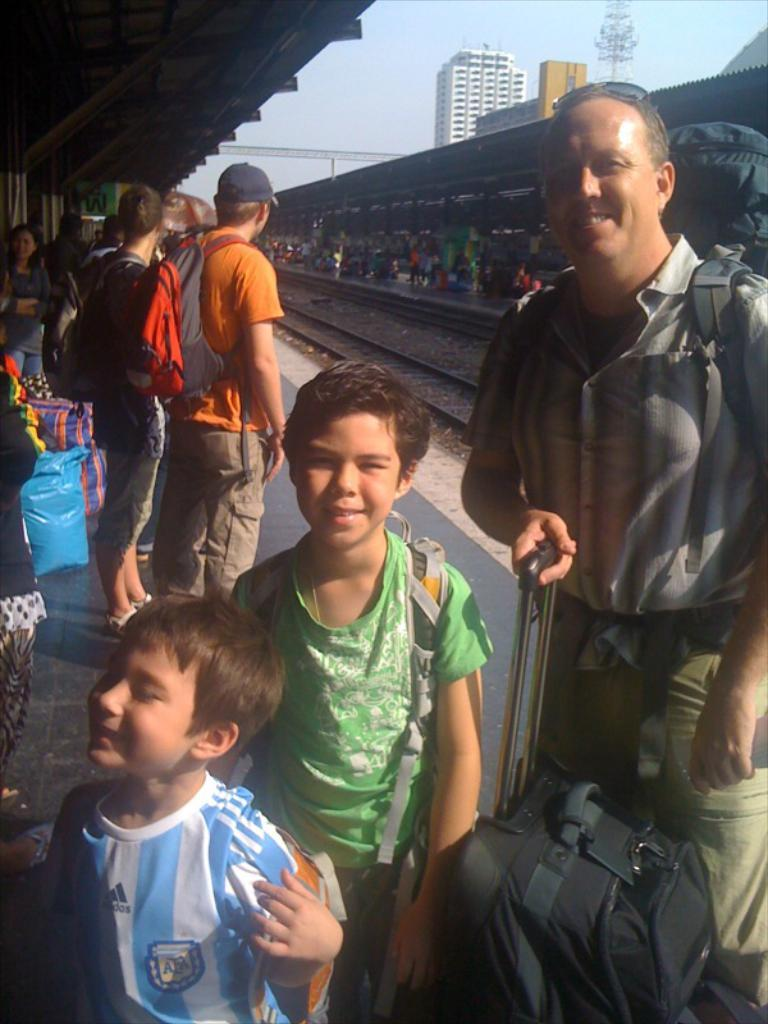What are the people in the image doing? The people in the image are standing on a platform. Can you describe the man on the left side of the platform? The man on the left side of the platform is holding a briefcase. What can be seen in the background of the image? There are railway tracks, buildings, and the sky visible in the background. What type of bird is perched on the chain in the image? There is no bird or chain present in the image. 